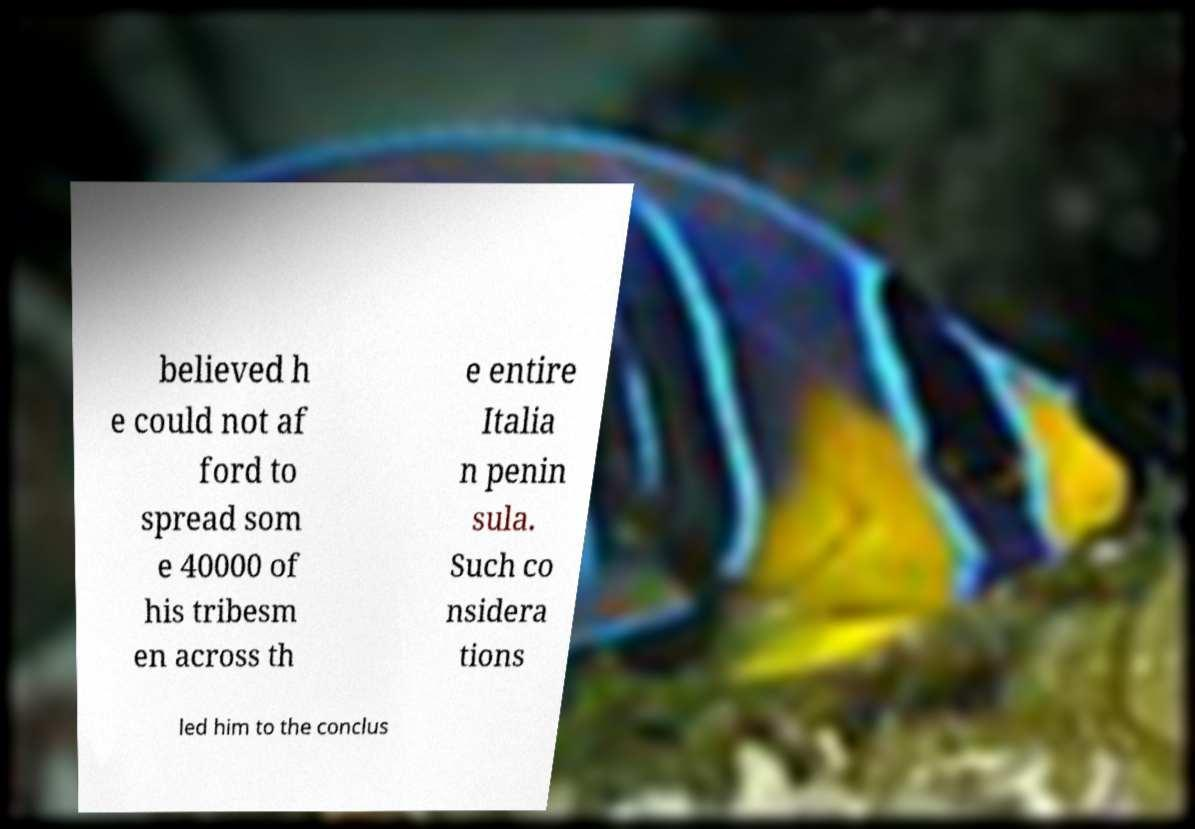I need the written content from this picture converted into text. Can you do that? believed h e could not af ford to spread som e 40000 of his tribesm en across th e entire Italia n penin sula. Such co nsidera tions led him to the conclus 